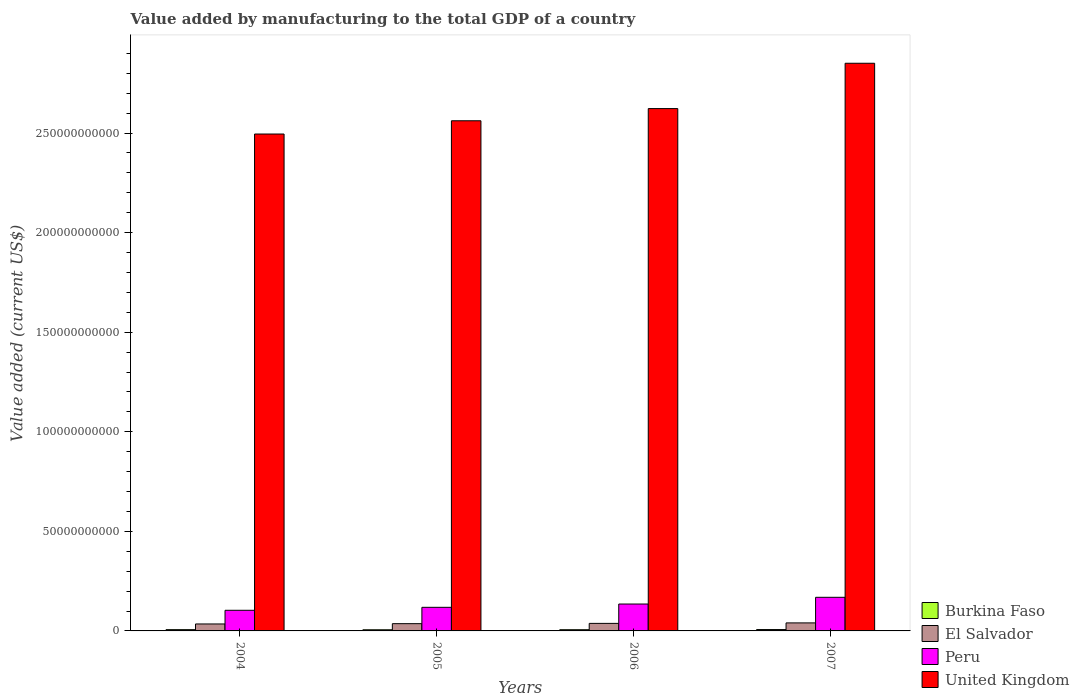Are the number of bars on each tick of the X-axis equal?
Offer a terse response. Yes. In how many cases, is the number of bars for a given year not equal to the number of legend labels?
Give a very brief answer. 0. What is the value added by manufacturing to the total GDP in El Salvador in 2007?
Provide a succinct answer. 4.03e+09. Across all years, what is the maximum value added by manufacturing to the total GDP in El Salvador?
Offer a terse response. 4.03e+09. Across all years, what is the minimum value added by manufacturing to the total GDP in Peru?
Make the answer very short. 1.04e+1. In which year was the value added by manufacturing to the total GDP in Peru maximum?
Provide a short and direct response. 2007. In which year was the value added by manufacturing to the total GDP in United Kingdom minimum?
Give a very brief answer. 2004. What is the total value added by manufacturing to the total GDP in Peru in the graph?
Your answer should be compact. 5.26e+1. What is the difference between the value added by manufacturing to the total GDP in El Salvador in 2004 and that in 2006?
Your answer should be compact. -2.94e+08. What is the difference between the value added by manufacturing to the total GDP in United Kingdom in 2006 and the value added by manufacturing to the total GDP in Peru in 2004?
Give a very brief answer. 2.52e+11. What is the average value added by manufacturing to the total GDP in Peru per year?
Provide a succinct answer. 1.32e+1. In the year 2007, what is the difference between the value added by manufacturing to the total GDP in United Kingdom and value added by manufacturing to the total GDP in El Salvador?
Offer a terse response. 2.81e+11. What is the ratio of the value added by manufacturing to the total GDP in Burkina Faso in 2005 to that in 2007?
Make the answer very short. 0.84. Is the value added by manufacturing to the total GDP in Peru in 2005 less than that in 2007?
Keep it short and to the point. Yes. What is the difference between the highest and the second highest value added by manufacturing to the total GDP in Burkina Faso?
Make the answer very short. 4.65e+07. What is the difference between the highest and the lowest value added by manufacturing to the total GDP in Burkina Faso?
Make the answer very short. 1.08e+08. In how many years, is the value added by manufacturing to the total GDP in United Kingdom greater than the average value added by manufacturing to the total GDP in United Kingdom taken over all years?
Ensure brevity in your answer.  1. Is the sum of the value added by manufacturing to the total GDP in Burkina Faso in 2005 and 2007 greater than the maximum value added by manufacturing to the total GDP in United Kingdom across all years?
Offer a very short reply. No. What does the 1st bar from the left in 2004 represents?
Offer a very short reply. Burkina Faso. What does the 3rd bar from the right in 2005 represents?
Offer a terse response. El Salvador. Is it the case that in every year, the sum of the value added by manufacturing to the total GDP in Peru and value added by manufacturing to the total GDP in El Salvador is greater than the value added by manufacturing to the total GDP in Burkina Faso?
Your answer should be very brief. Yes. Are all the bars in the graph horizontal?
Keep it short and to the point. No. Does the graph contain any zero values?
Your answer should be very brief. No. How are the legend labels stacked?
Offer a very short reply. Vertical. What is the title of the graph?
Keep it short and to the point. Value added by manufacturing to the total GDP of a country. What is the label or title of the Y-axis?
Your answer should be very brief. Value added (current US$). What is the Value added (current US$) of Burkina Faso in 2004?
Keep it short and to the point. 6.38e+08. What is the Value added (current US$) in El Salvador in 2004?
Make the answer very short. 3.50e+09. What is the Value added (current US$) of Peru in 2004?
Your response must be concise. 1.04e+1. What is the Value added (current US$) of United Kingdom in 2004?
Ensure brevity in your answer.  2.50e+11. What is the Value added (current US$) of Burkina Faso in 2005?
Your response must be concise. 5.77e+08. What is the Value added (current US$) in El Salvador in 2005?
Ensure brevity in your answer.  3.65e+09. What is the Value added (current US$) in Peru in 2005?
Ensure brevity in your answer.  1.19e+1. What is the Value added (current US$) in United Kingdom in 2005?
Your answer should be very brief. 2.56e+11. What is the Value added (current US$) of Burkina Faso in 2006?
Offer a very short reply. 6.10e+08. What is the Value added (current US$) of El Salvador in 2006?
Offer a terse response. 3.79e+09. What is the Value added (current US$) in Peru in 2006?
Your answer should be very brief. 1.35e+1. What is the Value added (current US$) in United Kingdom in 2006?
Offer a terse response. 2.62e+11. What is the Value added (current US$) of Burkina Faso in 2007?
Ensure brevity in your answer.  6.85e+08. What is the Value added (current US$) in El Salvador in 2007?
Your answer should be very brief. 4.03e+09. What is the Value added (current US$) in Peru in 2007?
Keep it short and to the point. 1.69e+1. What is the Value added (current US$) of United Kingdom in 2007?
Your response must be concise. 2.85e+11. Across all years, what is the maximum Value added (current US$) of Burkina Faso?
Your response must be concise. 6.85e+08. Across all years, what is the maximum Value added (current US$) of El Salvador?
Give a very brief answer. 4.03e+09. Across all years, what is the maximum Value added (current US$) of Peru?
Your response must be concise. 1.69e+1. Across all years, what is the maximum Value added (current US$) in United Kingdom?
Make the answer very short. 2.85e+11. Across all years, what is the minimum Value added (current US$) in Burkina Faso?
Your response must be concise. 5.77e+08. Across all years, what is the minimum Value added (current US$) of El Salvador?
Your answer should be compact. 3.50e+09. Across all years, what is the minimum Value added (current US$) in Peru?
Provide a short and direct response. 1.04e+1. Across all years, what is the minimum Value added (current US$) in United Kingdom?
Offer a terse response. 2.50e+11. What is the total Value added (current US$) of Burkina Faso in the graph?
Offer a very short reply. 2.51e+09. What is the total Value added (current US$) of El Salvador in the graph?
Make the answer very short. 1.50e+1. What is the total Value added (current US$) of Peru in the graph?
Keep it short and to the point. 5.26e+1. What is the total Value added (current US$) in United Kingdom in the graph?
Make the answer very short. 1.05e+12. What is the difference between the Value added (current US$) in Burkina Faso in 2004 and that in 2005?
Provide a succinct answer. 6.10e+07. What is the difference between the Value added (current US$) in El Salvador in 2004 and that in 2005?
Ensure brevity in your answer.  -1.52e+08. What is the difference between the Value added (current US$) of Peru in 2004 and that in 2005?
Your answer should be compact. -1.49e+09. What is the difference between the Value added (current US$) of United Kingdom in 2004 and that in 2005?
Your answer should be very brief. -6.65e+09. What is the difference between the Value added (current US$) of Burkina Faso in 2004 and that in 2006?
Keep it short and to the point. 2.84e+07. What is the difference between the Value added (current US$) of El Salvador in 2004 and that in 2006?
Provide a short and direct response. -2.94e+08. What is the difference between the Value added (current US$) in Peru in 2004 and that in 2006?
Make the answer very short. -3.15e+09. What is the difference between the Value added (current US$) in United Kingdom in 2004 and that in 2006?
Give a very brief answer. -1.28e+1. What is the difference between the Value added (current US$) in Burkina Faso in 2004 and that in 2007?
Provide a succinct answer. -4.65e+07. What is the difference between the Value added (current US$) of El Salvador in 2004 and that in 2007?
Provide a short and direct response. -5.30e+08. What is the difference between the Value added (current US$) of Peru in 2004 and that in 2007?
Provide a short and direct response. -6.51e+09. What is the difference between the Value added (current US$) in United Kingdom in 2004 and that in 2007?
Provide a succinct answer. -3.55e+1. What is the difference between the Value added (current US$) of Burkina Faso in 2005 and that in 2006?
Your response must be concise. -3.26e+07. What is the difference between the Value added (current US$) in El Salvador in 2005 and that in 2006?
Provide a succinct answer. -1.41e+08. What is the difference between the Value added (current US$) of Peru in 2005 and that in 2006?
Make the answer very short. -1.65e+09. What is the difference between the Value added (current US$) in United Kingdom in 2005 and that in 2006?
Provide a short and direct response. -6.12e+09. What is the difference between the Value added (current US$) of Burkina Faso in 2005 and that in 2007?
Your response must be concise. -1.08e+08. What is the difference between the Value added (current US$) in El Salvador in 2005 and that in 2007?
Offer a terse response. -3.78e+08. What is the difference between the Value added (current US$) in Peru in 2005 and that in 2007?
Make the answer very short. -5.02e+09. What is the difference between the Value added (current US$) of United Kingdom in 2005 and that in 2007?
Ensure brevity in your answer.  -2.89e+1. What is the difference between the Value added (current US$) of Burkina Faso in 2006 and that in 2007?
Your response must be concise. -7.49e+07. What is the difference between the Value added (current US$) of El Salvador in 2006 and that in 2007?
Your answer should be very brief. -2.37e+08. What is the difference between the Value added (current US$) of Peru in 2006 and that in 2007?
Offer a very short reply. -3.37e+09. What is the difference between the Value added (current US$) in United Kingdom in 2006 and that in 2007?
Make the answer very short. -2.28e+1. What is the difference between the Value added (current US$) in Burkina Faso in 2004 and the Value added (current US$) in El Salvador in 2005?
Your answer should be compact. -3.01e+09. What is the difference between the Value added (current US$) of Burkina Faso in 2004 and the Value added (current US$) of Peru in 2005?
Keep it short and to the point. -1.12e+1. What is the difference between the Value added (current US$) in Burkina Faso in 2004 and the Value added (current US$) in United Kingdom in 2005?
Offer a very short reply. -2.56e+11. What is the difference between the Value added (current US$) in El Salvador in 2004 and the Value added (current US$) in Peru in 2005?
Your answer should be compact. -8.36e+09. What is the difference between the Value added (current US$) of El Salvador in 2004 and the Value added (current US$) of United Kingdom in 2005?
Offer a terse response. -2.53e+11. What is the difference between the Value added (current US$) in Peru in 2004 and the Value added (current US$) in United Kingdom in 2005?
Your response must be concise. -2.46e+11. What is the difference between the Value added (current US$) of Burkina Faso in 2004 and the Value added (current US$) of El Salvador in 2006?
Provide a succinct answer. -3.15e+09. What is the difference between the Value added (current US$) of Burkina Faso in 2004 and the Value added (current US$) of Peru in 2006?
Give a very brief answer. -1.29e+1. What is the difference between the Value added (current US$) of Burkina Faso in 2004 and the Value added (current US$) of United Kingdom in 2006?
Your answer should be very brief. -2.62e+11. What is the difference between the Value added (current US$) in El Salvador in 2004 and the Value added (current US$) in Peru in 2006?
Keep it short and to the point. -1.00e+1. What is the difference between the Value added (current US$) in El Salvador in 2004 and the Value added (current US$) in United Kingdom in 2006?
Keep it short and to the point. -2.59e+11. What is the difference between the Value added (current US$) of Peru in 2004 and the Value added (current US$) of United Kingdom in 2006?
Ensure brevity in your answer.  -2.52e+11. What is the difference between the Value added (current US$) of Burkina Faso in 2004 and the Value added (current US$) of El Salvador in 2007?
Offer a terse response. -3.39e+09. What is the difference between the Value added (current US$) of Burkina Faso in 2004 and the Value added (current US$) of Peru in 2007?
Your answer should be very brief. -1.62e+1. What is the difference between the Value added (current US$) in Burkina Faso in 2004 and the Value added (current US$) in United Kingdom in 2007?
Your answer should be very brief. -2.84e+11. What is the difference between the Value added (current US$) of El Salvador in 2004 and the Value added (current US$) of Peru in 2007?
Provide a short and direct response. -1.34e+1. What is the difference between the Value added (current US$) in El Salvador in 2004 and the Value added (current US$) in United Kingdom in 2007?
Provide a short and direct response. -2.82e+11. What is the difference between the Value added (current US$) in Peru in 2004 and the Value added (current US$) in United Kingdom in 2007?
Offer a very short reply. -2.75e+11. What is the difference between the Value added (current US$) in Burkina Faso in 2005 and the Value added (current US$) in El Salvador in 2006?
Offer a terse response. -3.21e+09. What is the difference between the Value added (current US$) of Burkina Faso in 2005 and the Value added (current US$) of Peru in 2006?
Offer a very short reply. -1.29e+1. What is the difference between the Value added (current US$) of Burkina Faso in 2005 and the Value added (current US$) of United Kingdom in 2006?
Provide a short and direct response. -2.62e+11. What is the difference between the Value added (current US$) of El Salvador in 2005 and the Value added (current US$) of Peru in 2006?
Your response must be concise. -9.86e+09. What is the difference between the Value added (current US$) in El Salvador in 2005 and the Value added (current US$) in United Kingdom in 2006?
Your answer should be compact. -2.59e+11. What is the difference between the Value added (current US$) of Peru in 2005 and the Value added (current US$) of United Kingdom in 2006?
Make the answer very short. -2.50e+11. What is the difference between the Value added (current US$) in Burkina Faso in 2005 and the Value added (current US$) in El Salvador in 2007?
Offer a very short reply. -3.45e+09. What is the difference between the Value added (current US$) of Burkina Faso in 2005 and the Value added (current US$) of Peru in 2007?
Provide a succinct answer. -1.63e+1. What is the difference between the Value added (current US$) in Burkina Faso in 2005 and the Value added (current US$) in United Kingdom in 2007?
Your answer should be very brief. -2.84e+11. What is the difference between the Value added (current US$) in El Salvador in 2005 and the Value added (current US$) in Peru in 2007?
Offer a very short reply. -1.32e+1. What is the difference between the Value added (current US$) in El Salvador in 2005 and the Value added (current US$) in United Kingdom in 2007?
Keep it short and to the point. -2.81e+11. What is the difference between the Value added (current US$) of Peru in 2005 and the Value added (current US$) of United Kingdom in 2007?
Offer a terse response. -2.73e+11. What is the difference between the Value added (current US$) of Burkina Faso in 2006 and the Value added (current US$) of El Salvador in 2007?
Make the answer very short. -3.42e+09. What is the difference between the Value added (current US$) in Burkina Faso in 2006 and the Value added (current US$) in Peru in 2007?
Your answer should be very brief. -1.63e+1. What is the difference between the Value added (current US$) in Burkina Faso in 2006 and the Value added (current US$) in United Kingdom in 2007?
Your answer should be very brief. -2.84e+11. What is the difference between the Value added (current US$) in El Salvador in 2006 and the Value added (current US$) in Peru in 2007?
Your response must be concise. -1.31e+1. What is the difference between the Value added (current US$) in El Salvador in 2006 and the Value added (current US$) in United Kingdom in 2007?
Your response must be concise. -2.81e+11. What is the difference between the Value added (current US$) in Peru in 2006 and the Value added (current US$) in United Kingdom in 2007?
Keep it short and to the point. -2.72e+11. What is the average Value added (current US$) of Burkina Faso per year?
Your answer should be compact. 6.28e+08. What is the average Value added (current US$) of El Salvador per year?
Offer a very short reply. 3.74e+09. What is the average Value added (current US$) in Peru per year?
Your answer should be very brief. 1.32e+1. What is the average Value added (current US$) in United Kingdom per year?
Keep it short and to the point. 2.63e+11. In the year 2004, what is the difference between the Value added (current US$) of Burkina Faso and Value added (current US$) of El Salvador?
Your answer should be very brief. -2.86e+09. In the year 2004, what is the difference between the Value added (current US$) in Burkina Faso and Value added (current US$) in Peru?
Keep it short and to the point. -9.72e+09. In the year 2004, what is the difference between the Value added (current US$) of Burkina Faso and Value added (current US$) of United Kingdom?
Give a very brief answer. -2.49e+11. In the year 2004, what is the difference between the Value added (current US$) in El Salvador and Value added (current US$) in Peru?
Ensure brevity in your answer.  -6.87e+09. In the year 2004, what is the difference between the Value added (current US$) of El Salvador and Value added (current US$) of United Kingdom?
Provide a short and direct response. -2.46e+11. In the year 2004, what is the difference between the Value added (current US$) in Peru and Value added (current US$) in United Kingdom?
Keep it short and to the point. -2.39e+11. In the year 2005, what is the difference between the Value added (current US$) in Burkina Faso and Value added (current US$) in El Salvador?
Your answer should be compact. -3.07e+09. In the year 2005, what is the difference between the Value added (current US$) in Burkina Faso and Value added (current US$) in Peru?
Offer a very short reply. -1.13e+1. In the year 2005, what is the difference between the Value added (current US$) in Burkina Faso and Value added (current US$) in United Kingdom?
Offer a terse response. -2.56e+11. In the year 2005, what is the difference between the Value added (current US$) in El Salvador and Value added (current US$) in Peru?
Your response must be concise. -8.21e+09. In the year 2005, what is the difference between the Value added (current US$) in El Salvador and Value added (current US$) in United Kingdom?
Make the answer very short. -2.53e+11. In the year 2005, what is the difference between the Value added (current US$) in Peru and Value added (current US$) in United Kingdom?
Keep it short and to the point. -2.44e+11. In the year 2006, what is the difference between the Value added (current US$) in Burkina Faso and Value added (current US$) in El Salvador?
Your response must be concise. -3.18e+09. In the year 2006, what is the difference between the Value added (current US$) of Burkina Faso and Value added (current US$) of Peru?
Keep it short and to the point. -1.29e+1. In the year 2006, what is the difference between the Value added (current US$) in Burkina Faso and Value added (current US$) in United Kingdom?
Keep it short and to the point. -2.62e+11. In the year 2006, what is the difference between the Value added (current US$) in El Salvador and Value added (current US$) in Peru?
Provide a succinct answer. -9.72e+09. In the year 2006, what is the difference between the Value added (current US$) in El Salvador and Value added (current US$) in United Kingdom?
Your answer should be very brief. -2.58e+11. In the year 2006, what is the difference between the Value added (current US$) in Peru and Value added (current US$) in United Kingdom?
Your response must be concise. -2.49e+11. In the year 2007, what is the difference between the Value added (current US$) of Burkina Faso and Value added (current US$) of El Salvador?
Ensure brevity in your answer.  -3.34e+09. In the year 2007, what is the difference between the Value added (current US$) of Burkina Faso and Value added (current US$) of Peru?
Ensure brevity in your answer.  -1.62e+1. In the year 2007, what is the difference between the Value added (current US$) in Burkina Faso and Value added (current US$) in United Kingdom?
Offer a terse response. -2.84e+11. In the year 2007, what is the difference between the Value added (current US$) in El Salvador and Value added (current US$) in Peru?
Ensure brevity in your answer.  -1.29e+1. In the year 2007, what is the difference between the Value added (current US$) in El Salvador and Value added (current US$) in United Kingdom?
Provide a succinct answer. -2.81e+11. In the year 2007, what is the difference between the Value added (current US$) in Peru and Value added (current US$) in United Kingdom?
Provide a succinct answer. -2.68e+11. What is the ratio of the Value added (current US$) of Burkina Faso in 2004 to that in 2005?
Provide a succinct answer. 1.11. What is the ratio of the Value added (current US$) in Peru in 2004 to that in 2005?
Your response must be concise. 0.87. What is the ratio of the Value added (current US$) of United Kingdom in 2004 to that in 2005?
Offer a terse response. 0.97. What is the ratio of the Value added (current US$) in Burkina Faso in 2004 to that in 2006?
Offer a very short reply. 1.05. What is the ratio of the Value added (current US$) in El Salvador in 2004 to that in 2006?
Give a very brief answer. 0.92. What is the ratio of the Value added (current US$) of Peru in 2004 to that in 2006?
Provide a short and direct response. 0.77. What is the ratio of the Value added (current US$) in United Kingdom in 2004 to that in 2006?
Your response must be concise. 0.95. What is the ratio of the Value added (current US$) of Burkina Faso in 2004 to that in 2007?
Your answer should be compact. 0.93. What is the ratio of the Value added (current US$) in El Salvador in 2004 to that in 2007?
Your answer should be compact. 0.87. What is the ratio of the Value added (current US$) of Peru in 2004 to that in 2007?
Give a very brief answer. 0.61. What is the ratio of the Value added (current US$) of United Kingdom in 2004 to that in 2007?
Provide a short and direct response. 0.88. What is the ratio of the Value added (current US$) in Burkina Faso in 2005 to that in 2006?
Provide a succinct answer. 0.95. What is the ratio of the Value added (current US$) of El Salvador in 2005 to that in 2006?
Provide a succinct answer. 0.96. What is the ratio of the Value added (current US$) in Peru in 2005 to that in 2006?
Offer a terse response. 0.88. What is the ratio of the Value added (current US$) in United Kingdom in 2005 to that in 2006?
Offer a terse response. 0.98. What is the ratio of the Value added (current US$) of Burkina Faso in 2005 to that in 2007?
Your answer should be very brief. 0.84. What is the ratio of the Value added (current US$) of El Salvador in 2005 to that in 2007?
Provide a short and direct response. 0.91. What is the ratio of the Value added (current US$) of Peru in 2005 to that in 2007?
Keep it short and to the point. 0.7. What is the ratio of the Value added (current US$) in United Kingdom in 2005 to that in 2007?
Ensure brevity in your answer.  0.9. What is the ratio of the Value added (current US$) in Burkina Faso in 2006 to that in 2007?
Give a very brief answer. 0.89. What is the ratio of the Value added (current US$) of Peru in 2006 to that in 2007?
Provide a succinct answer. 0.8. What is the ratio of the Value added (current US$) in United Kingdom in 2006 to that in 2007?
Give a very brief answer. 0.92. What is the difference between the highest and the second highest Value added (current US$) in Burkina Faso?
Your answer should be compact. 4.65e+07. What is the difference between the highest and the second highest Value added (current US$) of El Salvador?
Keep it short and to the point. 2.37e+08. What is the difference between the highest and the second highest Value added (current US$) in Peru?
Give a very brief answer. 3.37e+09. What is the difference between the highest and the second highest Value added (current US$) in United Kingdom?
Offer a terse response. 2.28e+1. What is the difference between the highest and the lowest Value added (current US$) in Burkina Faso?
Give a very brief answer. 1.08e+08. What is the difference between the highest and the lowest Value added (current US$) in El Salvador?
Your response must be concise. 5.30e+08. What is the difference between the highest and the lowest Value added (current US$) of Peru?
Give a very brief answer. 6.51e+09. What is the difference between the highest and the lowest Value added (current US$) in United Kingdom?
Offer a very short reply. 3.55e+1. 